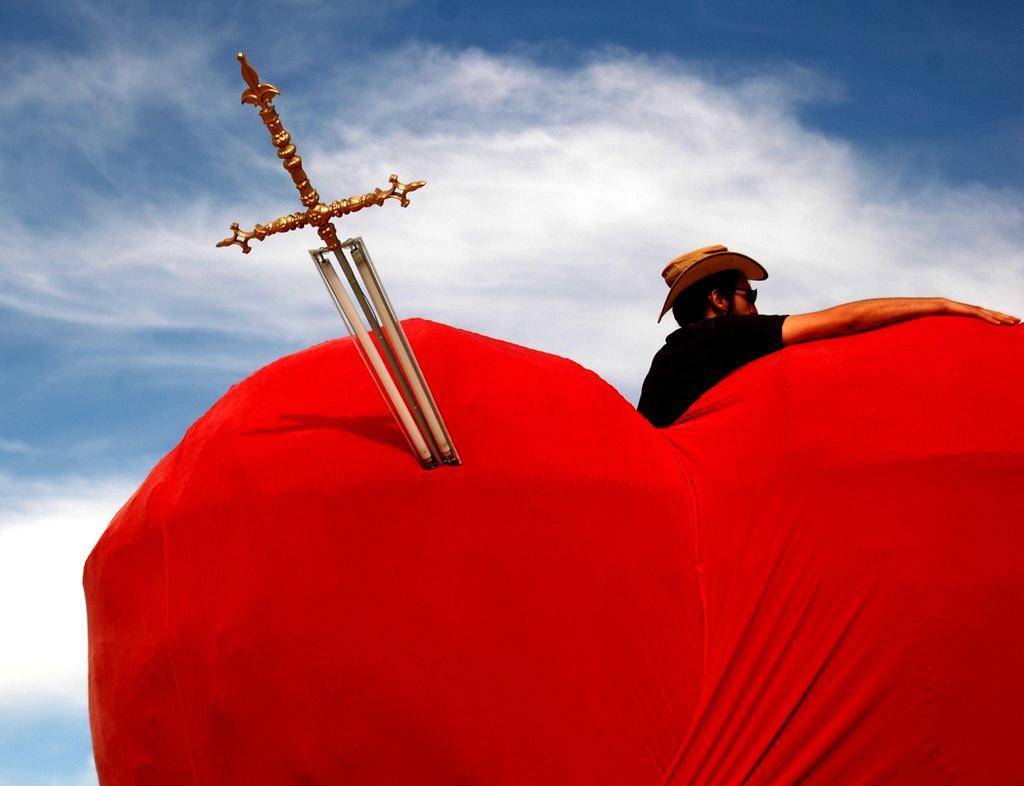Can you describe this image briefly? In this image I can see a sword. I can see a man. I can see a heart shaped object. It is red in color. 